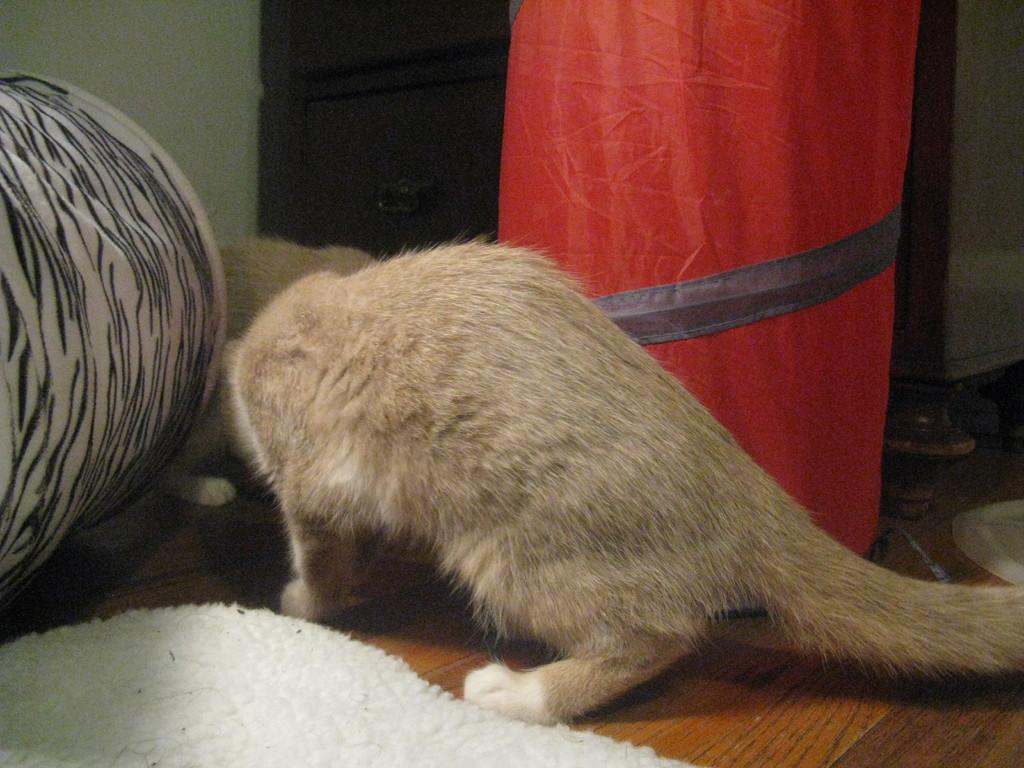What type of animals can be seen in the image? There are cats in the image. What objects are present in the image that can be used for carrying items? There are baskets in the image. What is on the floor in the image? There is a carpet on the floor in the image. Where can footwear be found in the image? Footwear can be found on the right side of the image. What type of rod is used to play baseball in the image? There is no baseball or rod present in the image; it features cats, baskets, a carpet, and footwear. 